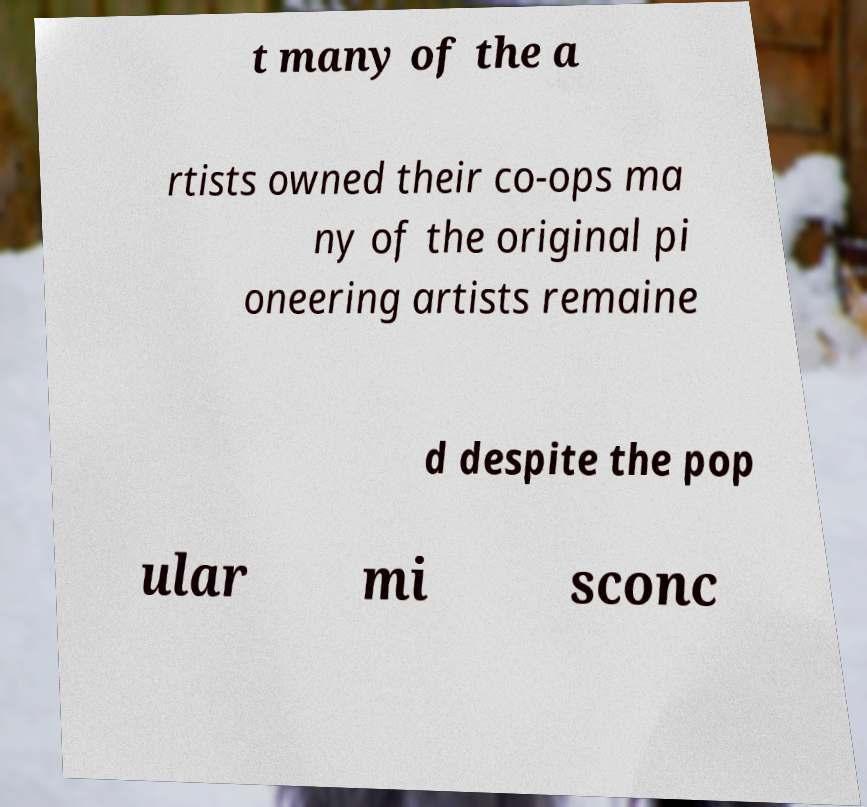Could you extract and type out the text from this image? t many of the a rtists owned their co-ops ma ny of the original pi oneering artists remaine d despite the pop ular mi sconc 